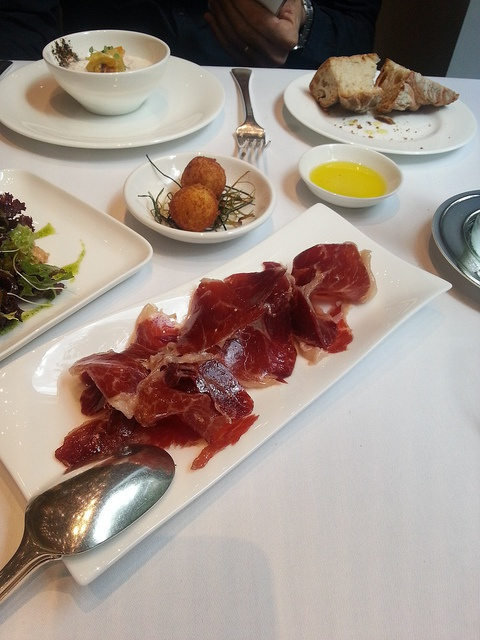Describe the objects in this image and their specific colors. I can see dining table in lightgray, darkgray, and maroon tones, spoon in black, maroon, gray, and white tones, bowl in black, lightgray, brown, maroon, and darkgray tones, bowl in black, darkgray, lightgray, and tan tones, and bowl in black, gold, darkgray, lightgray, and beige tones in this image. 